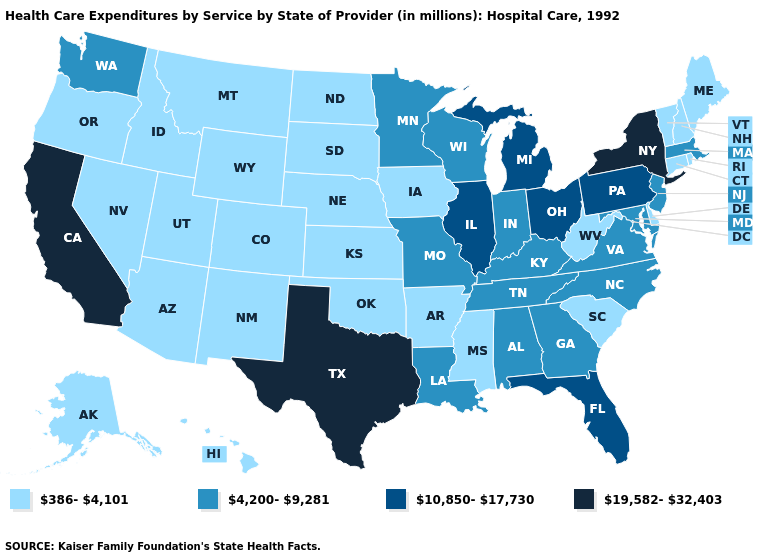Name the states that have a value in the range 4,200-9,281?
Give a very brief answer. Alabama, Georgia, Indiana, Kentucky, Louisiana, Maryland, Massachusetts, Minnesota, Missouri, New Jersey, North Carolina, Tennessee, Virginia, Washington, Wisconsin. Does Georgia have the lowest value in the USA?
Be succinct. No. What is the value of Maryland?
Keep it brief. 4,200-9,281. Name the states that have a value in the range 19,582-32,403?
Write a very short answer. California, New York, Texas. Name the states that have a value in the range 386-4,101?
Be succinct. Alaska, Arizona, Arkansas, Colorado, Connecticut, Delaware, Hawaii, Idaho, Iowa, Kansas, Maine, Mississippi, Montana, Nebraska, Nevada, New Hampshire, New Mexico, North Dakota, Oklahoma, Oregon, Rhode Island, South Carolina, South Dakota, Utah, Vermont, West Virginia, Wyoming. What is the value of Mississippi?
Keep it brief. 386-4,101. What is the lowest value in the USA?
Give a very brief answer. 386-4,101. What is the lowest value in the Northeast?
Answer briefly. 386-4,101. What is the value of Kansas?
Be succinct. 386-4,101. How many symbols are there in the legend?
Answer briefly. 4. Name the states that have a value in the range 4,200-9,281?
Quick response, please. Alabama, Georgia, Indiana, Kentucky, Louisiana, Maryland, Massachusetts, Minnesota, Missouri, New Jersey, North Carolina, Tennessee, Virginia, Washington, Wisconsin. Which states have the lowest value in the South?
Concise answer only. Arkansas, Delaware, Mississippi, Oklahoma, South Carolina, West Virginia. Does Texas have a higher value than California?
Give a very brief answer. No. Which states hav the highest value in the South?
Keep it brief. Texas. How many symbols are there in the legend?
Give a very brief answer. 4. 